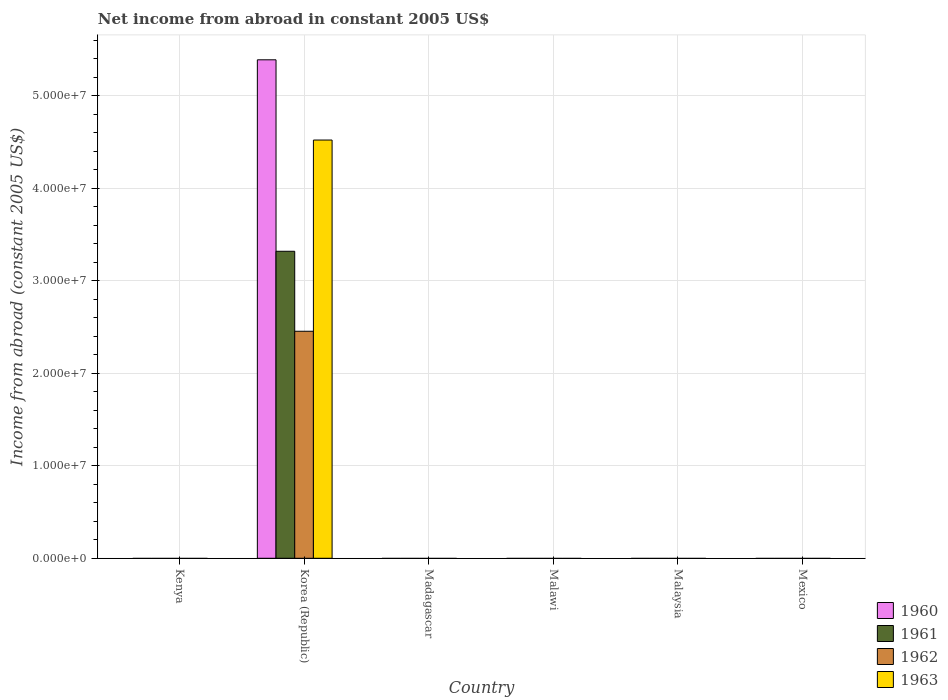Are the number of bars on each tick of the X-axis equal?
Provide a succinct answer. No. How many bars are there on the 3rd tick from the left?
Make the answer very short. 0. What is the label of the 3rd group of bars from the left?
Your response must be concise. Madagascar. Across all countries, what is the maximum net income from abroad in 1962?
Provide a succinct answer. 2.45e+07. Across all countries, what is the minimum net income from abroad in 1962?
Keep it short and to the point. 0. What is the total net income from abroad in 1962 in the graph?
Keep it short and to the point. 2.45e+07. What is the average net income from abroad in 1961 per country?
Make the answer very short. 5.53e+06. What is the difference between the net income from abroad of/in 1961 and net income from abroad of/in 1963 in Korea (Republic)?
Offer a terse response. -1.20e+07. In how many countries, is the net income from abroad in 1963 greater than 12000000 US$?
Your response must be concise. 1. What is the difference between the highest and the lowest net income from abroad in 1963?
Keep it short and to the point. 4.52e+07. Is it the case that in every country, the sum of the net income from abroad in 1961 and net income from abroad in 1962 is greater than the sum of net income from abroad in 1963 and net income from abroad in 1960?
Provide a succinct answer. No. Is it the case that in every country, the sum of the net income from abroad in 1960 and net income from abroad in 1961 is greater than the net income from abroad in 1962?
Give a very brief answer. No. Are all the bars in the graph horizontal?
Provide a succinct answer. No. How many countries are there in the graph?
Provide a short and direct response. 6. Does the graph contain any zero values?
Provide a succinct answer. Yes. Does the graph contain grids?
Ensure brevity in your answer.  Yes. What is the title of the graph?
Offer a terse response. Net income from abroad in constant 2005 US$. What is the label or title of the Y-axis?
Provide a short and direct response. Income from abroad (constant 2005 US$). What is the Income from abroad (constant 2005 US$) in 1961 in Kenya?
Keep it short and to the point. 0. What is the Income from abroad (constant 2005 US$) in 1962 in Kenya?
Offer a terse response. 0. What is the Income from abroad (constant 2005 US$) in 1960 in Korea (Republic)?
Your response must be concise. 5.39e+07. What is the Income from abroad (constant 2005 US$) in 1961 in Korea (Republic)?
Your answer should be compact. 3.32e+07. What is the Income from abroad (constant 2005 US$) in 1962 in Korea (Republic)?
Keep it short and to the point. 2.45e+07. What is the Income from abroad (constant 2005 US$) of 1963 in Korea (Republic)?
Your answer should be very brief. 4.52e+07. What is the Income from abroad (constant 2005 US$) in 1960 in Madagascar?
Provide a succinct answer. 0. What is the Income from abroad (constant 2005 US$) of 1961 in Madagascar?
Ensure brevity in your answer.  0. What is the Income from abroad (constant 2005 US$) of 1960 in Malaysia?
Keep it short and to the point. 0. What is the Income from abroad (constant 2005 US$) in 1962 in Malaysia?
Provide a short and direct response. 0. What is the Income from abroad (constant 2005 US$) of 1962 in Mexico?
Provide a succinct answer. 0. Across all countries, what is the maximum Income from abroad (constant 2005 US$) in 1960?
Keep it short and to the point. 5.39e+07. Across all countries, what is the maximum Income from abroad (constant 2005 US$) in 1961?
Provide a short and direct response. 3.32e+07. Across all countries, what is the maximum Income from abroad (constant 2005 US$) of 1962?
Provide a short and direct response. 2.45e+07. Across all countries, what is the maximum Income from abroad (constant 2005 US$) of 1963?
Your response must be concise. 4.52e+07. Across all countries, what is the minimum Income from abroad (constant 2005 US$) in 1961?
Your response must be concise. 0. Across all countries, what is the minimum Income from abroad (constant 2005 US$) of 1962?
Provide a succinct answer. 0. Across all countries, what is the minimum Income from abroad (constant 2005 US$) of 1963?
Your answer should be very brief. 0. What is the total Income from abroad (constant 2005 US$) of 1960 in the graph?
Offer a terse response. 5.39e+07. What is the total Income from abroad (constant 2005 US$) in 1961 in the graph?
Give a very brief answer. 3.32e+07. What is the total Income from abroad (constant 2005 US$) of 1962 in the graph?
Your answer should be compact. 2.45e+07. What is the total Income from abroad (constant 2005 US$) of 1963 in the graph?
Offer a very short reply. 4.52e+07. What is the average Income from abroad (constant 2005 US$) of 1960 per country?
Provide a succinct answer. 8.98e+06. What is the average Income from abroad (constant 2005 US$) of 1961 per country?
Your answer should be compact. 5.53e+06. What is the average Income from abroad (constant 2005 US$) in 1962 per country?
Your response must be concise. 4.09e+06. What is the average Income from abroad (constant 2005 US$) of 1963 per country?
Ensure brevity in your answer.  7.54e+06. What is the difference between the Income from abroad (constant 2005 US$) of 1960 and Income from abroad (constant 2005 US$) of 1961 in Korea (Republic)?
Give a very brief answer. 2.07e+07. What is the difference between the Income from abroad (constant 2005 US$) in 1960 and Income from abroad (constant 2005 US$) in 1962 in Korea (Republic)?
Offer a terse response. 2.94e+07. What is the difference between the Income from abroad (constant 2005 US$) of 1960 and Income from abroad (constant 2005 US$) of 1963 in Korea (Republic)?
Your response must be concise. 8.68e+06. What is the difference between the Income from abroad (constant 2005 US$) of 1961 and Income from abroad (constant 2005 US$) of 1962 in Korea (Republic)?
Give a very brief answer. 8.65e+06. What is the difference between the Income from abroad (constant 2005 US$) of 1961 and Income from abroad (constant 2005 US$) of 1963 in Korea (Republic)?
Give a very brief answer. -1.20e+07. What is the difference between the Income from abroad (constant 2005 US$) in 1962 and Income from abroad (constant 2005 US$) in 1963 in Korea (Republic)?
Provide a succinct answer. -2.07e+07. What is the difference between the highest and the lowest Income from abroad (constant 2005 US$) in 1960?
Keep it short and to the point. 5.39e+07. What is the difference between the highest and the lowest Income from abroad (constant 2005 US$) in 1961?
Your answer should be very brief. 3.32e+07. What is the difference between the highest and the lowest Income from abroad (constant 2005 US$) in 1962?
Offer a very short reply. 2.45e+07. What is the difference between the highest and the lowest Income from abroad (constant 2005 US$) in 1963?
Provide a short and direct response. 4.52e+07. 